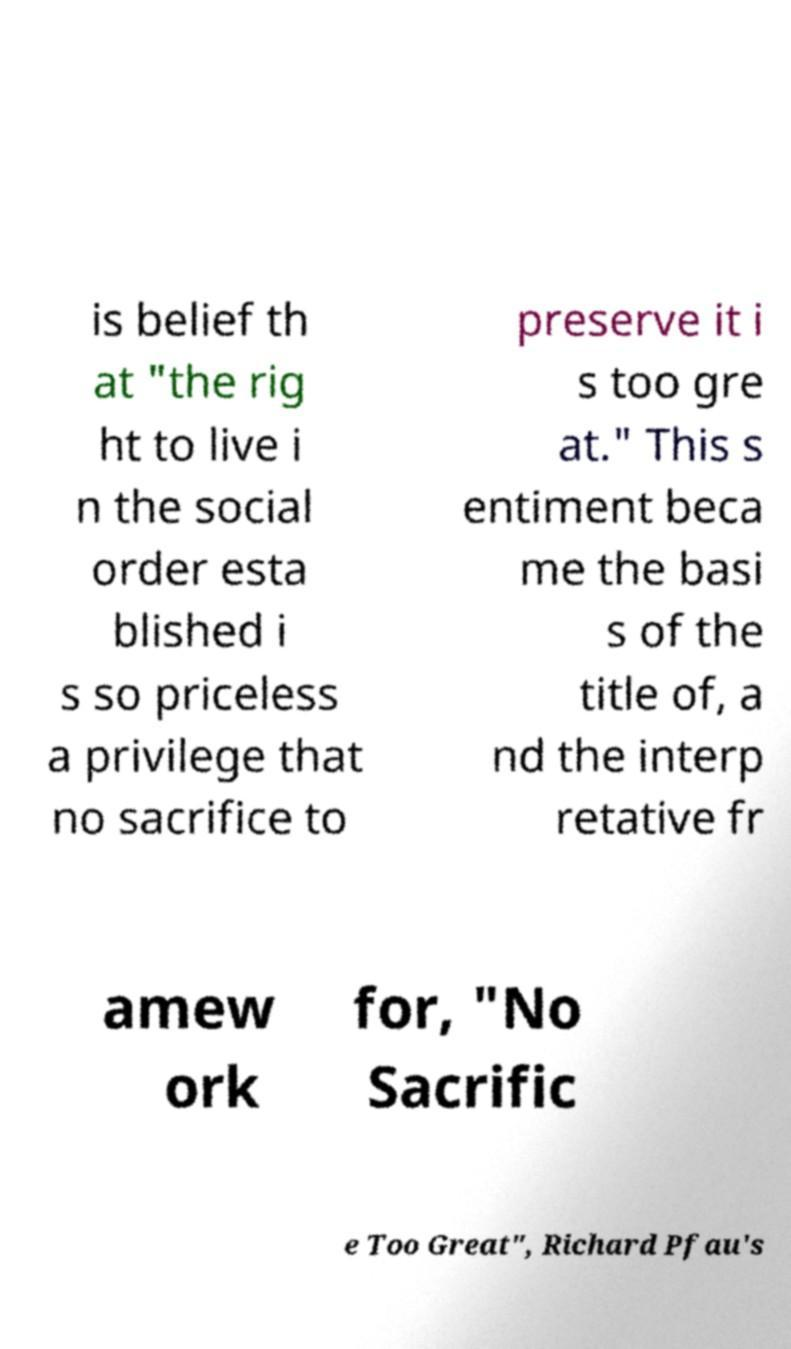Could you assist in decoding the text presented in this image and type it out clearly? is belief th at "the rig ht to live i n the social order esta blished i s so priceless a privilege that no sacrifice to preserve it i s too gre at." This s entiment beca me the basi s of the title of, a nd the interp retative fr amew ork for, "No Sacrific e Too Great", Richard Pfau's 